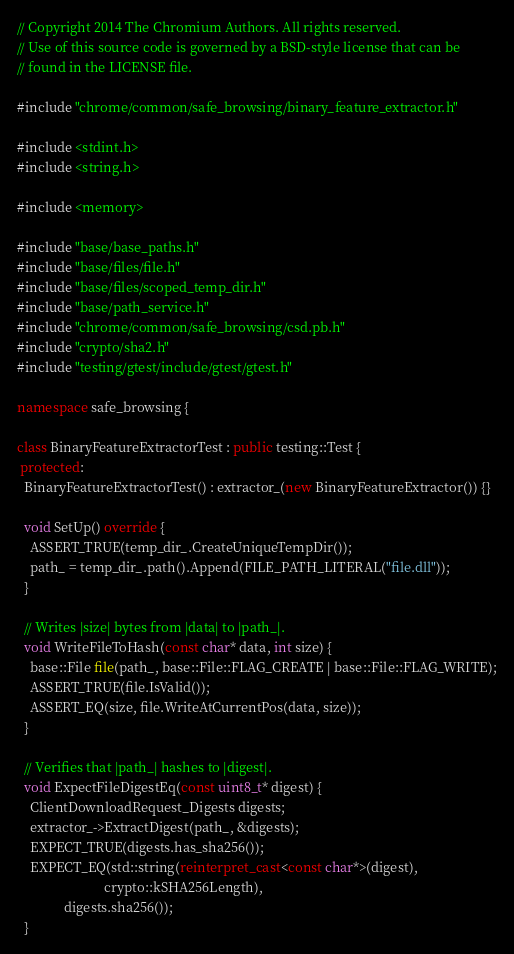Convert code to text. <code><loc_0><loc_0><loc_500><loc_500><_C++_>// Copyright 2014 The Chromium Authors. All rights reserved.
// Use of this source code is governed by a BSD-style license that can be
// found in the LICENSE file.

#include "chrome/common/safe_browsing/binary_feature_extractor.h"

#include <stdint.h>
#include <string.h>

#include <memory>

#include "base/base_paths.h"
#include "base/files/file.h"
#include "base/files/scoped_temp_dir.h"
#include "base/path_service.h"
#include "chrome/common/safe_browsing/csd.pb.h"
#include "crypto/sha2.h"
#include "testing/gtest/include/gtest/gtest.h"

namespace safe_browsing {

class BinaryFeatureExtractorTest : public testing::Test {
 protected:
  BinaryFeatureExtractorTest() : extractor_(new BinaryFeatureExtractor()) {}

  void SetUp() override {
    ASSERT_TRUE(temp_dir_.CreateUniqueTempDir());
    path_ = temp_dir_.path().Append(FILE_PATH_LITERAL("file.dll"));
  }

  // Writes |size| bytes from |data| to |path_|.
  void WriteFileToHash(const char* data, int size) {
    base::File file(path_, base::File::FLAG_CREATE | base::File::FLAG_WRITE);
    ASSERT_TRUE(file.IsValid());
    ASSERT_EQ(size, file.WriteAtCurrentPos(data, size));
  }

  // Verifies that |path_| hashes to |digest|.
  void ExpectFileDigestEq(const uint8_t* digest) {
    ClientDownloadRequest_Digests digests;
    extractor_->ExtractDigest(path_, &digests);
    EXPECT_TRUE(digests.has_sha256());
    EXPECT_EQ(std::string(reinterpret_cast<const char*>(digest),
                          crypto::kSHA256Length),
              digests.sha256());
  }
</code> 